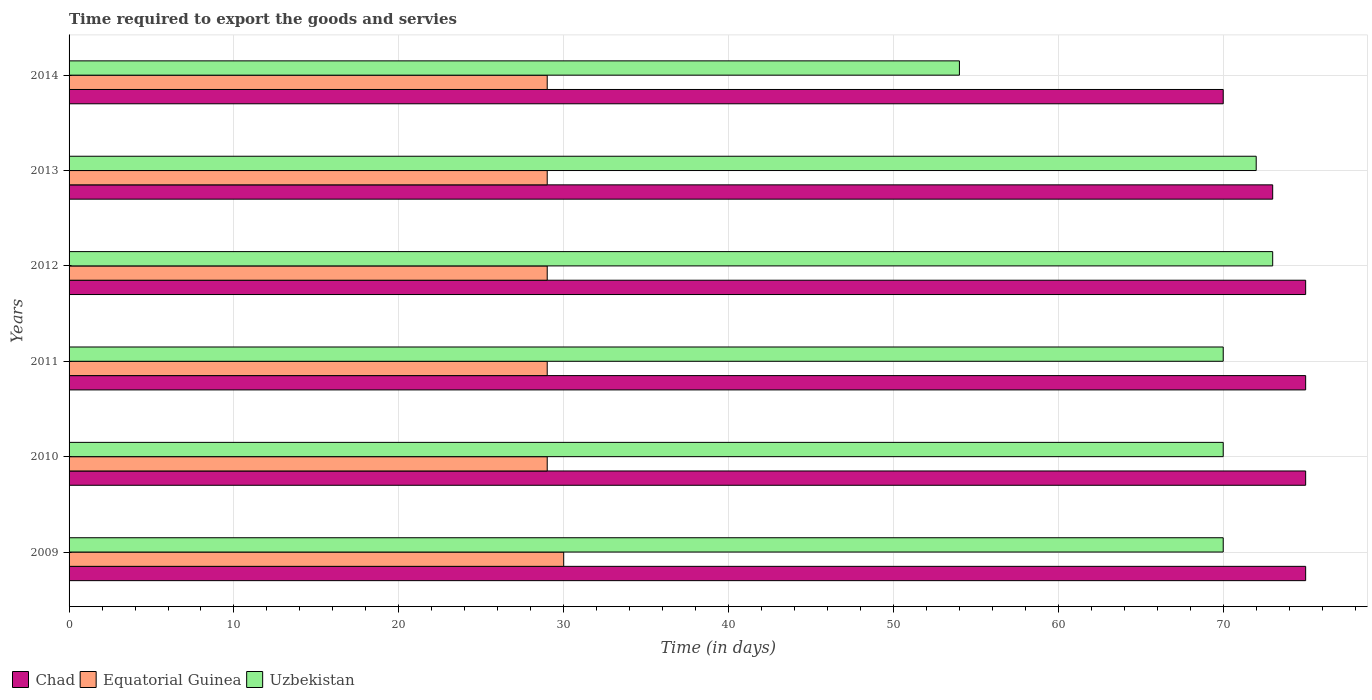How many groups of bars are there?
Offer a very short reply. 6. What is the label of the 4th group of bars from the top?
Your answer should be compact. 2011. In how many cases, is the number of bars for a given year not equal to the number of legend labels?
Keep it short and to the point. 0. What is the number of days required to export the goods and services in Equatorial Guinea in 2013?
Offer a terse response. 29. Across all years, what is the maximum number of days required to export the goods and services in Chad?
Provide a succinct answer. 75. Across all years, what is the minimum number of days required to export the goods and services in Equatorial Guinea?
Give a very brief answer. 29. In which year was the number of days required to export the goods and services in Chad maximum?
Give a very brief answer. 2009. In which year was the number of days required to export the goods and services in Equatorial Guinea minimum?
Offer a terse response. 2010. What is the total number of days required to export the goods and services in Uzbekistan in the graph?
Offer a very short reply. 409. What is the difference between the number of days required to export the goods and services in Chad in 2009 and the number of days required to export the goods and services in Uzbekistan in 2012?
Keep it short and to the point. 2. What is the average number of days required to export the goods and services in Equatorial Guinea per year?
Provide a succinct answer. 29.17. In the year 2014, what is the difference between the number of days required to export the goods and services in Uzbekistan and number of days required to export the goods and services in Chad?
Give a very brief answer. -16. In how many years, is the number of days required to export the goods and services in Equatorial Guinea greater than 22 days?
Give a very brief answer. 6. What is the ratio of the number of days required to export the goods and services in Equatorial Guinea in 2010 to that in 2014?
Offer a very short reply. 1. What is the difference between the highest and the lowest number of days required to export the goods and services in Chad?
Provide a short and direct response. 5. In how many years, is the number of days required to export the goods and services in Equatorial Guinea greater than the average number of days required to export the goods and services in Equatorial Guinea taken over all years?
Your response must be concise. 1. What does the 1st bar from the top in 2012 represents?
Offer a terse response. Uzbekistan. What does the 3rd bar from the bottom in 2013 represents?
Provide a short and direct response. Uzbekistan. Are all the bars in the graph horizontal?
Offer a terse response. Yes. How many years are there in the graph?
Your response must be concise. 6. Where does the legend appear in the graph?
Offer a terse response. Bottom left. How many legend labels are there?
Provide a short and direct response. 3. What is the title of the graph?
Make the answer very short. Time required to export the goods and servies. What is the label or title of the X-axis?
Your response must be concise. Time (in days). What is the Time (in days) of Chad in 2009?
Keep it short and to the point. 75. What is the Time (in days) of Uzbekistan in 2009?
Keep it short and to the point. 70. What is the Time (in days) in Uzbekistan in 2010?
Your response must be concise. 70. What is the Time (in days) in Equatorial Guinea in 2011?
Ensure brevity in your answer.  29. What is the Time (in days) in Uzbekistan in 2011?
Provide a succinct answer. 70. What is the Time (in days) of Chad in 2012?
Provide a short and direct response. 75. What is the Time (in days) in Equatorial Guinea in 2012?
Offer a terse response. 29. What is the Time (in days) in Equatorial Guinea in 2013?
Give a very brief answer. 29. What is the Time (in days) in Uzbekistan in 2013?
Give a very brief answer. 72. What is the Time (in days) in Uzbekistan in 2014?
Make the answer very short. 54. Across all years, what is the maximum Time (in days) of Chad?
Ensure brevity in your answer.  75. Across all years, what is the maximum Time (in days) of Equatorial Guinea?
Provide a short and direct response. 30. Across all years, what is the minimum Time (in days) of Chad?
Offer a terse response. 70. Across all years, what is the minimum Time (in days) of Equatorial Guinea?
Your response must be concise. 29. What is the total Time (in days) in Chad in the graph?
Provide a short and direct response. 443. What is the total Time (in days) in Equatorial Guinea in the graph?
Make the answer very short. 175. What is the total Time (in days) in Uzbekistan in the graph?
Provide a short and direct response. 409. What is the difference between the Time (in days) of Uzbekistan in 2009 and that in 2010?
Ensure brevity in your answer.  0. What is the difference between the Time (in days) of Chad in 2009 and that in 2012?
Make the answer very short. 0. What is the difference between the Time (in days) in Uzbekistan in 2009 and that in 2013?
Make the answer very short. -2. What is the difference between the Time (in days) of Uzbekistan in 2009 and that in 2014?
Provide a succinct answer. 16. What is the difference between the Time (in days) in Chad in 2010 and that in 2011?
Provide a short and direct response. 0. What is the difference between the Time (in days) of Uzbekistan in 2010 and that in 2011?
Your answer should be very brief. 0. What is the difference between the Time (in days) in Equatorial Guinea in 2010 and that in 2012?
Offer a terse response. 0. What is the difference between the Time (in days) of Uzbekistan in 2010 and that in 2012?
Your answer should be very brief. -3. What is the difference between the Time (in days) of Chad in 2010 and that in 2013?
Offer a very short reply. 2. What is the difference between the Time (in days) in Equatorial Guinea in 2010 and that in 2013?
Your response must be concise. 0. What is the difference between the Time (in days) in Uzbekistan in 2010 and that in 2013?
Give a very brief answer. -2. What is the difference between the Time (in days) in Chad in 2010 and that in 2014?
Your answer should be compact. 5. What is the difference between the Time (in days) of Equatorial Guinea in 2010 and that in 2014?
Give a very brief answer. 0. What is the difference between the Time (in days) of Chad in 2011 and that in 2012?
Give a very brief answer. 0. What is the difference between the Time (in days) of Uzbekistan in 2011 and that in 2012?
Your answer should be compact. -3. What is the difference between the Time (in days) in Chad in 2011 and that in 2013?
Keep it short and to the point. 2. What is the difference between the Time (in days) in Equatorial Guinea in 2011 and that in 2013?
Your response must be concise. 0. What is the difference between the Time (in days) of Uzbekistan in 2011 and that in 2013?
Provide a succinct answer. -2. What is the difference between the Time (in days) in Chad in 2011 and that in 2014?
Your response must be concise. 5. What is the difference between the Time (in days) of Equatorial Guinea in 2011 and that in 2014?
Ensure brevity in your answer.  0. What is the difference between the Time (in days) in Chad in 2012 and that in 2013?
Offer a terse response. 2. What is the difference between the Time (in days) in Chad in 2012 and that in 2014?
Make the answer very short. 5. What is the difference between the Time (in days) of Equatorial Guinea in 2012 and that in 2014?
Ensure brevity in your answer.  0. What is the difference between the Time (in days) in Chad in 2013 and that in 2014?
Your response must be concise. 3. What is the difference between the Time (in days) in Equatorial Guinea in 2013 and that in 2014?
Your answer should be very brief. 0. What is the difference between the Time (in days) of Chad in 2009 and the Time (in days) of Equatorial Guinea in 2010?
Provide a succinct answer. 46. What is the difference between the Time (in days) of Equatorial Guinea in 2009 and the Time (in days) of Uzbekistan in 2010?
Your response must be concise. -40. What is the difference between the Time (in days) in Chad in 2009 and the Time (in days) in Uzbekistan in 2011?
Your response must be concise. 5. What is the difference between the Time (in days) in Equatorial Guinea in 2009 and the Time (in days) in Uzbekistan in 2012?
Make the answer very short. -43. What is the difference between the Time (in days) in Chad in 2009 and the Time (in days) in Equatorial Guinea in 2013?
Your answer should be compact. 46. What is the difference between the Time (in days) in Equatorial Guinea in 2009 and the Time (in days) in Uzbekistan in 2013?
Your answer should be very brief. -42. What is the difference between the Time (in days) of Equatorial Guinea in 2009 and the Time (in days) of Uzbekistan in 2014?
Offer a very short reply. -24. What is the difference between the Time (in days) in Chad in 2010 and the Time (in days) in Uzbekistan in 2011?
Your answer should be compact. 5. What is the difference between the Time (in days) in Equatorial Guinea in 2010 and the Time (in days) in Uzbekistan in 2011?
Provide a succinct answer. -41. What is the difference between the Time (in days) in Chad in 2010 and the Time (in days) in Equatorial Guinea in 2012?
Your answer should be compact. 46. What is the difference between the Time (in days) in Chad in 2010 and the Time (in days) in Uzbekistan in 2012?
Your answer should be compact. 2. What is the difference between the Time (in days) of Equatorial Guinea in 2010 and the Time (in days) of Uzbekistan in 2012?
Your answer should be compact. -44. What is the difference between the Time (in days) of Chad in 2010 and the Time (in days) of Uzbekistan in 2013?
Provide a short and direct response. 3. What is the difference between the Time (in days) of Equatorial Guinea in 2010 and the Time (in days) of Uzbekistan in 2013?
Ensure brevity in your answer.  -43. What is the difference between the Time (in days) of Chad in 2011 and the Time (in days) of Uzbekistan in 2012?
Offer a terse response. 2. What is the difference between the Time (in days) of Equatorial Guinea in 2011 and the Time (in days) of Uzbekistan in 2012?
Your answer should be very brief. -44. What is the difference between the Time (in days) of Chad in 2011 and the Time (in days) of Equatorial Guinea in 2013?
Offer a terse response. 46. What is the difference between the Time (in days) in Chad in 2011 and the Time (in days) in Uzbekistan in 2013?
Provide a short and direct response. 3. What is the difference between the Time (in days) in Equatorial Guinea in 2011 and the Time (in days) in Uzbekistan in 2013?
Offer a very short reply. -43. What is the difference between the Time (in days) in Chad in 2011 and the Time (in days) in Equatorial Guinea in 2014?
Provide a short and direct response. 46. What is the difference between the Time (in days) of Equatorial Guinea in 2012 and the Time (in days) of Uzbekistan in 2013?
Keep it short and to the point. -43. What is the difference between the Time (in days) of Equatorial Guinea in 2013 and the Time (in days) of Uzbekistan in 2014?
Your response must be concise. -25. What is the average Time (in days) in Chad per year?
Offer a terse response. 73.83. What is the average Time (in days) of Equatorial Guinea per year?
Ensure brevity in your answer.  29.17. What is the average Time (in days) in Uzbekistan per year?
Your answer should be very brief. 68.17. In the year 2009, what is the difference between the Time (in days) of Chad and Time (in days) of Equatorial Guinea?
Your answer should be compact. 45. In the year 2009, what is the difference between the Time (in days) of Chad and Time (in days) of Uzbekistan?
Give a very brief answer. 5. In the year 2010, what is the difference between the Time (in days) in Equatorial Guinea and Time (in days) in Uzbekistan?
Offer a very short reply. -41. In the year 2011, what is the difference between the Time (in days) of Chad and Time (in days) of Equatorial Guinea?
Offer a terse response. 46. In the year 2011, what is the difference between the Time (in days) in Equatorial Guinea and Time (in days) in Uzbekistan?
Offer a very short reply. -41. In the year 2012, what is the difference between the Time (in days) in Equatorial Guinea and Time (in days) in Uzbekistan?
Ensure brevity in your answer.  -44. In the year 2013, what is the difference between the Time (in days) of Chad and Time (in days) of Equatorial Guinea?
Offer a very short reply. 44. In the year 2013, what is the difference between the Time (in days) of Chad and Time (in days) of Uzbekistan?
Provide a succinct answer. 1. In the year 2013, what is the difference between the Time (in days) of Equatorial Guinea and Time (in days) of Uzbekistan?
Provide a short and direct response. -43. In the year 2014, what is the difference between the Time (in days) in Equatorial Guinea and Time (in days) in Uzbekistan?
Offer a very short reply. -25. What is the ratio of the Time (in days) in Chad in 2009 to that in 2010?
Offer a terse response. 1. What is the ratio of the Time (in days) of Equatorial Guinea in 2009 to that in 2010?
Offer a terse response. 1.03. What is the ratio of the Time (in days) in Equatorial Guinea in 2009 to that in 2011?
Offer a terse response. 1.03. What is the ratio of the Time (in days) in Chad in 2009 to that in 2012?
Your response must be concise. 1. What is the ratio of the Time (in days) in Equatorial Guinea in 2009 to that in 2012?
Provide a succinct answer. 1.03. What is the ratio of the Time (in days) of Uzbekistan in 2009 to that in 2012?
Offer a very short reply. 0.96. What is the ratio of the Time (in days) in Chad in 2009 to that in 2013?
Your answer should be very brief. 1.03. What is the ratio of the Time (in days) of Equatorial Guinea in 2009 to that in 2013?
Make the answer very short. 1.03. What is the ratio of the Time (in days) of Uzbekistan in 2009 to that in 2013?
Your answer should be compact. 0.97. What is the ratio of the Time (in days) of Chad in 2009 to that in 2014?
Give a very brief answer. 1.07. What is the ratio of the Time (in days) of Equatorial Guinea in 2009 to that in 2014?
Your response must be concise. 1.03. What is the ratio of the Time (in days) of Uzbekistan in 2009 to that in 2014?
Keep it short and to the point. 1.3. What is the ratio of the Time (in days) of Chad in 2010 to that in 2011?
Offer a terse response. 1. What is the ratio of the Time (in days) in Equatorial Guinea in 2010 to that in 2011?
Provide a succinct answer. 1. What is the ratio of the Time (in days) in Equatorial Guinea in 2010 to that in 2012?
Ensure brevity in your answer.  1. What is the ratio of the Time (in days) in Uzbekistan in 2010 to that in 2012?
Provide a succinct answer. 0.96. What is the ratio of the Time (in days) in Chad in 2010 to that in 2013?
Give a very brief answer. 1.03. What is the ratio of the Time (in days) in Equatorial Guinea in 2010 to that in 2013?
Provide a short and direct response. 1. What is the ratio of the Time (in days) of Uzbekistan in 2010 to that in 2013?
Keep it short and to the point. 0.97. What is the ratio of the Time (in days) of Chad in 2010 to that in 2014?
Ensure brevity in your answer.  1.07. What is the ratio of the Time (in days) in Uzbekistan in 2010 to that in 2014?
Provide a short and direct response. 1.3. What is the ratio of the Time (in days) of Chad in 2011 to that in 2012?
Your answer should be very brief. 1. What is the ratio of the Time (in days) of Equatorial Guinea in 2011 to that in 2012?
Your response must be concise. 1. What is the ratio of the Time (in days) in Uzbekistan in 2011 to that in 2012?
Give a very brief answer. 0.96. What is the ratio of the Time (in days) in Chad in 2011 to that in 2013?
Offer a very short reply. 1.03. What is the ratio of the Time (in days) of Uzbekistan in 2011 to that in 2013?
Provide a succinct answer. 0.97. What is the ratio of the Time (in days) in Chad in 2011 to that in 2014?
Give a very brief answer. 1.07. What is the ratio of the Time (in days) of Equatorial Guinea in 2011 to that in 2014?
Give a very brief answer. 1. What is the ratio of the Time (in days) of Uzbekistan in 2011 to that in 2014?
Ensure brevity in your answer.  1.3. What is the ratio of the Time (in days) in Chad in 2012 to that in 2013?
Your response must be concise. 1.03. What is the ratio of the Time (in days) in Equatorial Guinea in 2012 to that in 2013?
Offer a very short reply. 1. What is the ratio of the Time (in days) of Uzbekistan in 2012 to that in 2013?
Offer a terse response. 1.01. What is the ratio of the Time (in days) of Chad in 2012 to that in 2014?
Offer a very short reply. 1.07. What is the ratio of the Time (in days) in Equatorial Guinea in 2012 to that in 2014?
Give a very brief answer. 1. What is the ratio of the Time (in days) of Uzbekistan in 2012 to that in 2014?
Ensure brevity in your answer.  1.35. What is the ratio of the Time (in days) in Chad in 2013 to that in 2014?
Offer a terse response. 1.04. What is the ratio of the Time (in days) in Equatorial Guinea in 2013 to that in 2014?
Give a very brief answer. 1. What is the difference between the highest and the second highest Time (in days) of Chad?
Your answer should be very brief. 0. What is the difference between the highest and the second highest Time (in days) in Equatorial Guinea?
Give a very brief answer. 1. What is the difference between the highest and the lowest Time (in days) in Chad?
Provide a short and direct response. 5. 